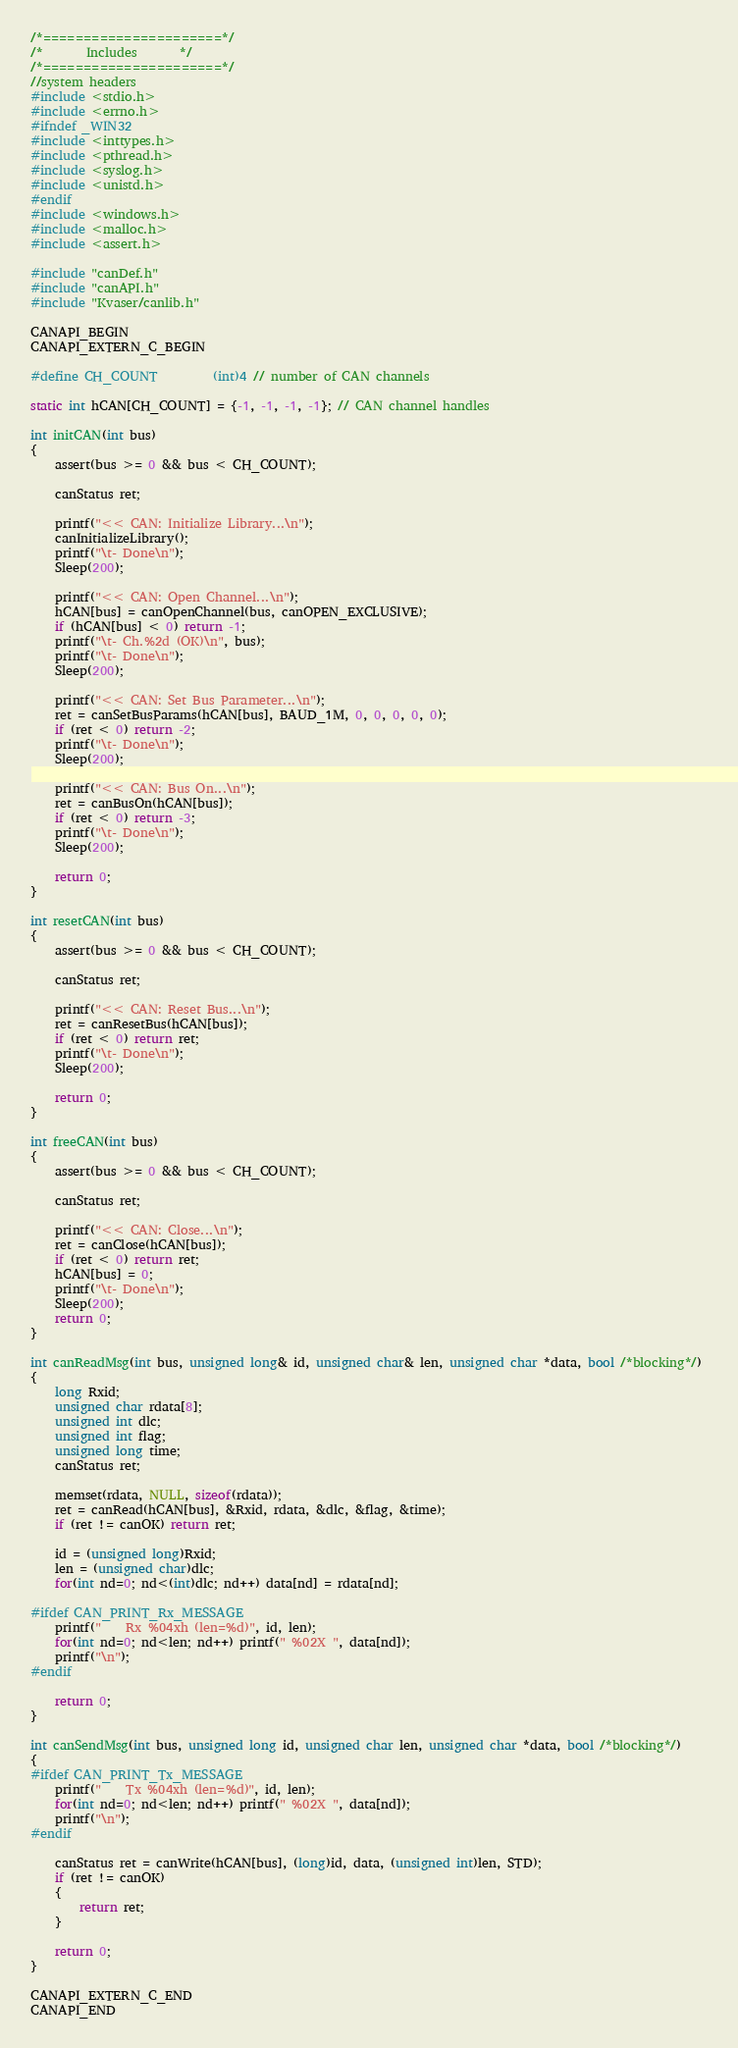<code> <loc_0><loc_0><loc_500><loc_500><_C++_>/*======================*/
/*       Includes       */
/*======================*/
//system headers
#include <stdio.h>
#include <errno.h>
#ifndef _WIN32
#include <inttypes.h>
#include <pthread.h>
#include <syslog.h>
#include <unistd.h>
#endif
#include <windows.h>
#include <malloc.h>
#include <assert.h>

#include "canDef.h"
#include "canAPI.h"
#include "Kvaser/canlib.h"

CANAPI_BEGIN
CANAPI_EXTERN_C_BEGIN

#define CH_COUNT			(int)4 // number of CAN channels

static int hCAN[CH_COUNT] = {-1, -1, -1, -1}; // CAN channel handles

int initCAN(int bus)
{
	assert(bus >= 0 && bus < CH_COUNT);

	canStatus ret;
	
	printf("<< CAN: Initialize Library...\n");
	canInitializeLibrary();
	printf("\t- Done\n");
	Sleep(200);

	printf("<< CAN: Open Channel...\n");
	hCAN[bus] = canOpenChannel(bus, canOPEN_EXCLUSIVE);
	if (hCAN[bus] < 0) return -1;
	printf("\t- Ch.%2d (OK)\n", bus);
	printf("\t- Done\n");
	Sleep(200);

	printf("<< CAN: Set Bus Parameter...\n");
	ret = canSetBusParams(hCAN[bus], BAUD_1M, 0, 0, 0, 0, 0);
	if (ret < 0) return -2;
	printf("\t- Done\n");
	Sleep(200);

	printf("<< CAN: Bus On...\n");
	ret = canBusOn(hCAN[bus]);
	if (ret < 0) return -3;
	printf("\t- Done\n");
	Sleep(200);

	return 0;
}

int resetCAN(int bus)
{
	assert(bus >= 0 && bus < CH_COUNT);

	canStatus ret;

	printf("<< CAN: Reset Bus...\n");
	ret = canResetBus(hCAN[bus]);
	if (ret < 0) return ret;
	printf("\t- Done\n");
	Sleep(200);

	return 0;
}

int freeCAN(int bus)
{
	assert(bus >= 0 && bus < CH_COUNT);

	canStatus ret;

	printf("<< CAN: Close...\n");
	ret = canClose(hCAN[bus]);
	if (ret < 0) return ret;
	hCAN[bus] = 0;
	printf("\t- Done\n");
	Sleep(200);
	return 0;
}

int canReadMsg(int bus, unsigned long& id, unsigned char& len, unsigned char *data, bool /*blocking*/) 
{
	long Rxid;
	unsigned char rdata[8];
	unsigned int dlc;
	unsigned int flag;
	unsigned long time;
	canStatus ret;

	memset(rdata, NULL, sizeof(rdata));
	ret = canRead(hCAN[bus], &Rxid, rdata, &dlc, &flag, &time);
	if (ret != canOK) return ret;

	id = (unsigned long)Rxid;
	len = (unsigned char)dlc;
	for(int nd=0; nd<(int)dlc; nd++) data[nd] = rdata[nd];

#ifdef CAN_PRINT_Rx_MESSAGE
	printf("    Rx %04xh (len=%d)", id, len);
	for(int nd=0; nd<len; nd++) printf(" %02X ", data[nd]);
	printf("\n");
#endif

	return 0;
}

int canSendMsg(int bus, unsigned long id, unsigned char len, unsigned char *data, bool /*blocking*/) 
{
#ifdef CAN_PRINT_Tx_MESSAGE
	printf("    Tx %04xh (len=%d)", id, len);
	for(int nd=0; nd<len; nd++) printf(" %02X ", data[nd]);
	printf("\n");
#endif

	canStatus ret = canWrite(hCAN[bus], (long)id, data, (unsigned int)len, STD);
	if (ret != canOK)
	{
		return ret;
	}

	return 0;
}

CANAPI_EXTERN_C_END
CANAPI_END
</code> 